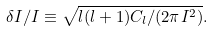Convert formula to latex. <formula><loc_0><loc_0><loc_500><loc_500>\delta I / I \equiv \sqrt { l ( l + 1 ) C _ { l } / ( 2 \pi I ^ { 2 } ) } .</formula> 